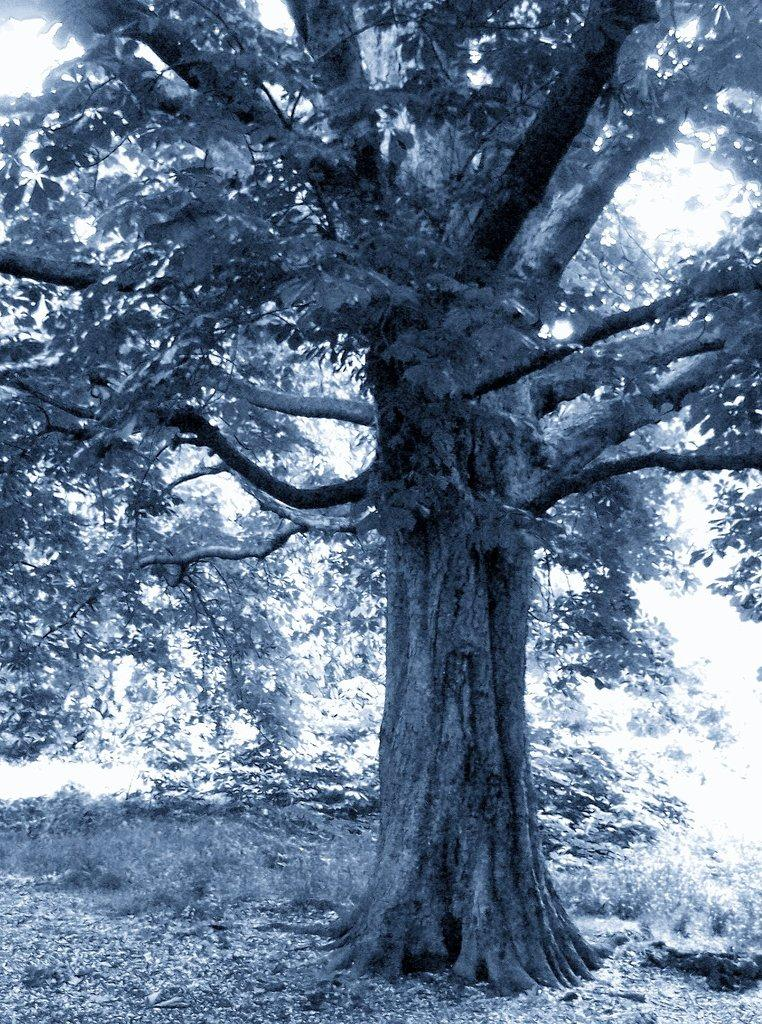Where was the image taken? The image was clicked outside the city. What can be seen in the foreground of the image? There is grass and leaves in the foreground of the image. What is the main object in the center of the image? There is a tree in the center of the image. What part of the natural environment is visible in the image? The sky is visible in the image. How did the father perform in the competition shown in the image? There is no father or competition present in the image. 